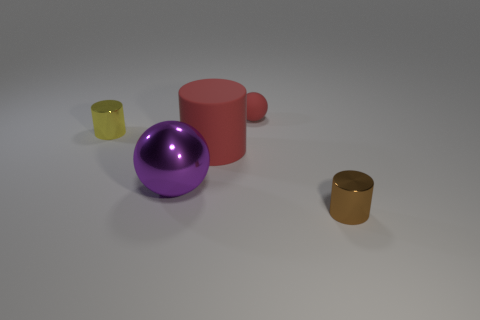How many objects are tiny shiny cylinders that are in front of the red matte cylinder or rubber balls left of the brown metal cylinder?
Provide a short and direct response. 2. How many other things are the same color as the big sphere?
Make the answer very short. 0. Is the number of objects that are right of the small yellow cylinder greater than the number of big purple balls that are on the left side of the purple metal thing?
Give a very brief answer. Yes. What number of balls are purple rubber things or tiny things?
Your answer should be compact. 1. How many things are either small metal cylinders that are to the left of the small brown object or blue matte things?
Provide a short and direct response. 1. There is a small metallic thing that is left of the tiny shiny object on the right side of the small cylinder that is behind the big matte cylinder; what is its shape?
Make the answer very short. Cylinder. How many other things have the same shape as the big purple object?
Ensure brevity in your answer.  1. There is a large object that is the same color as the small rubber ball; what is it made of?
Give a very brief answer. Rubber. Is the small brown cylinder made of the same material as the large purple object?
Offer a terse response. Yes. How many metallic objects are to the right of the sphere in front of the cylinder on the left side of the big red object?
Provide a short and direct response. 1. 